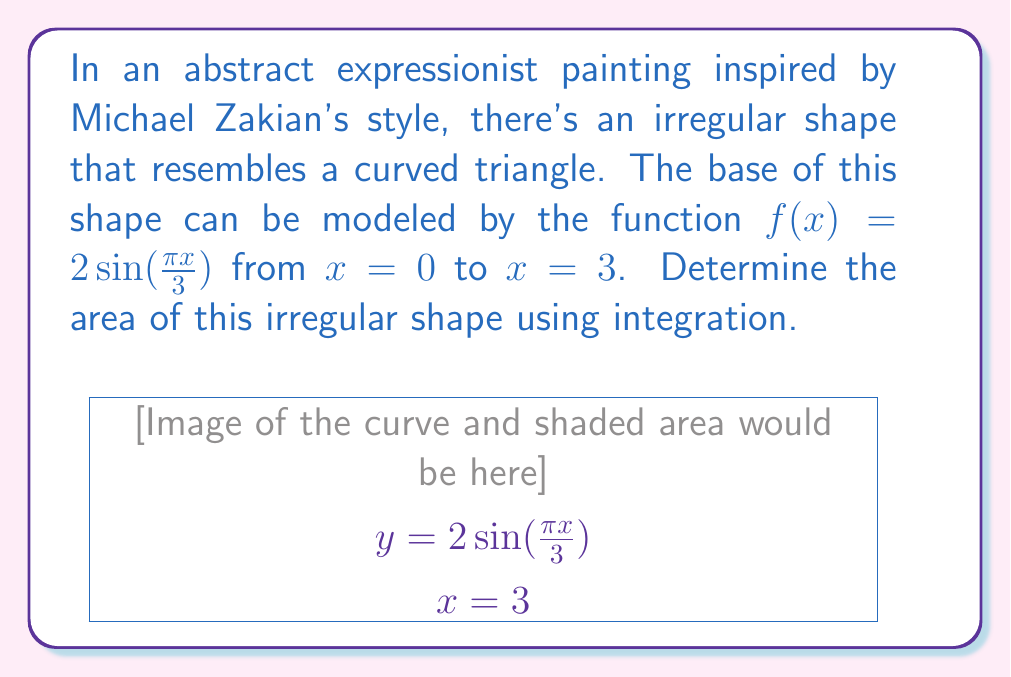Give your solution to this math problem. To find the area of this irregular shape, we need to integrate the function $f(x) = 2\sin(\frac{\pi x}{3})$ from $x=0$ to $x=3$. The area is given by the definite integral:

$$A = \int_0^3 2\sin(\frac{\pi x}{3}) dx$$

Let's solve this integral step by step:

1) First, we can factor out the constant 2:
   $$A = 2 \int_0^3 \sin(\frac{\pi x}{3}) dx$$

2) To integrate $\sin(\frac{\pi x}{3})$, we can use the substitution $u = \frac{\pi x}{3}$. This gives:
   $du = \frac{\pi}{3} dx$, or $dx = \frac{3}{\pi} du$

3) When $x = 0$, $u = 0$, and when $x = 3$, $u = \pi$. So our new integral becomes:
   $$A = 2 \cdot \frac{3}{\pi} \int_0^{\pi} \sin(u) du$$

4) The integral of $\sin(u)$ is $-\cos(u)$, so:
   $$A = \frac{6}{\pi} [-\cos(u)]_0^{\pi}$$

5) Evaluating this:
   $$A = \frac{6}{\pi} [-\cos(\pi) - (-\cos(0))]$$
   $$A = \frac{6}{\pi} [1 - (-1)] = \frac{6}{\pi} \cdot 2 = \frac{12}{\pi}$$

Thus, the area of the irregular shape is $\frac{12}{\pi}$ square units.
Answer: $\frac{12}{\pi}$ square units 